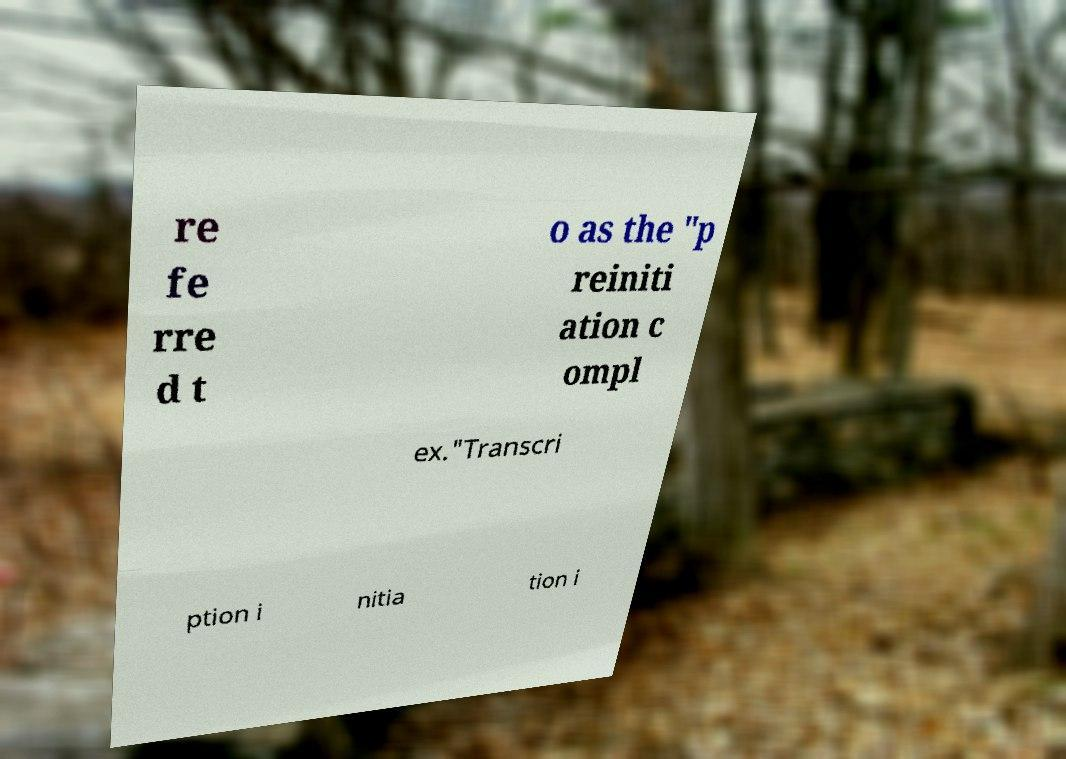For documentation purposes, I need the text within this image transcribed. Could you provide that? re fe rre d t o as the "p reiniti ation c ompl ex."Transcri ption i nitia tion i 